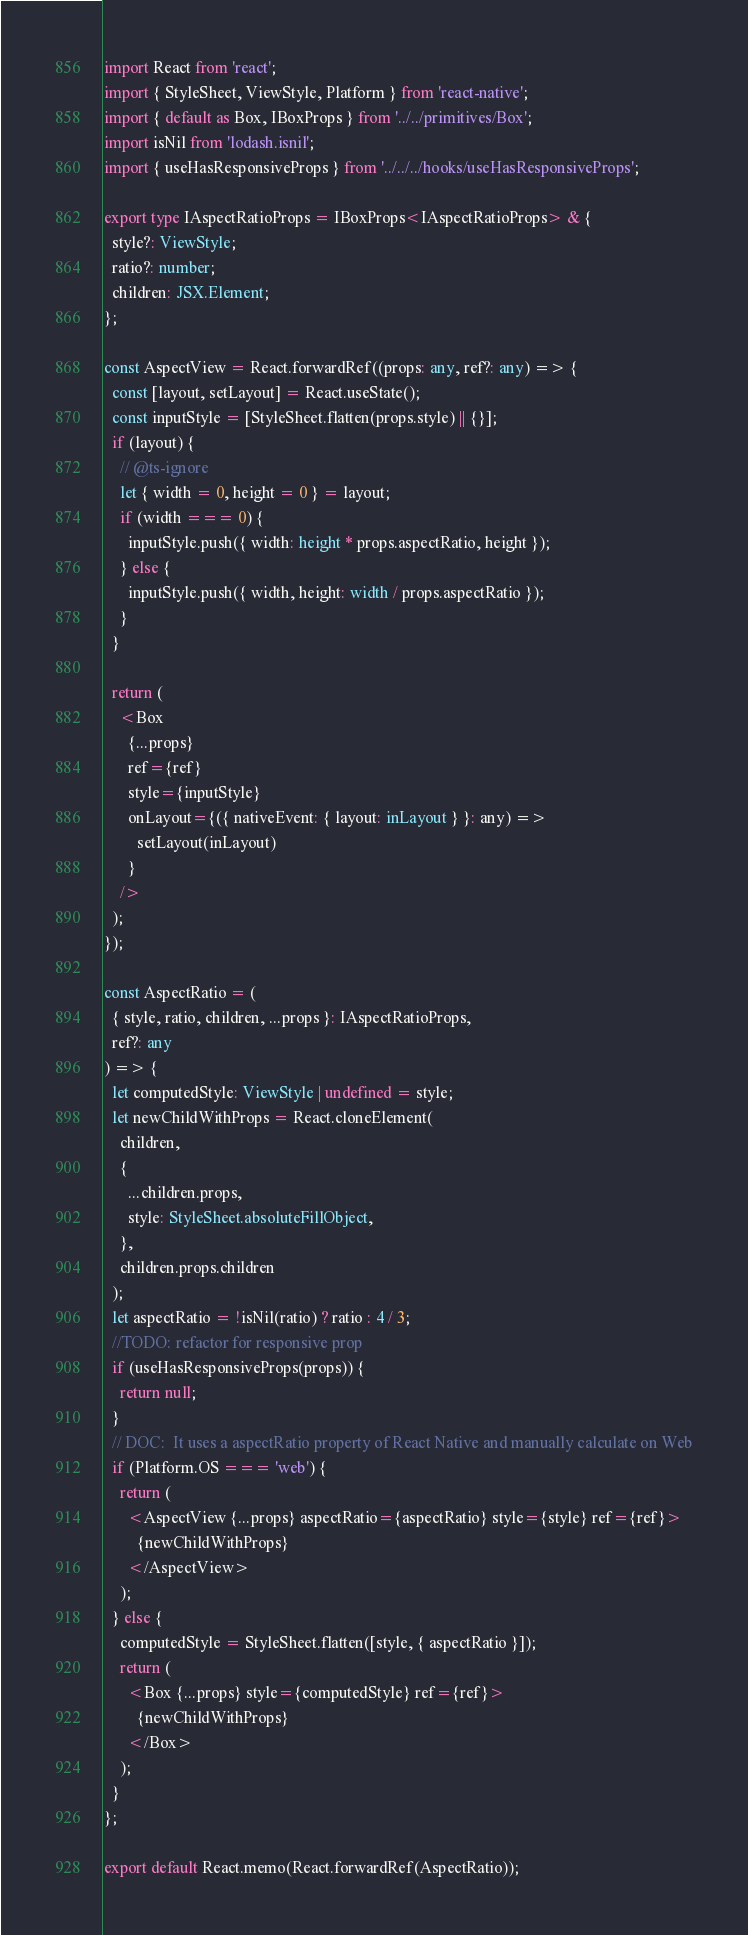Convert code to text. <code><loc_0><loc_0><loc_500><loc_500><_TypeScript_>import React from 'react';
import { StyleSheet, ViewStyle, Platform } from 'react-native';
import { default as Box, IBoxProps } from '../../primitives/Box';
import isNil from 'lodash.isnil';
import { useHasResponsiveProps } from '../../../hooks/useHasResponsiveProps';

export type IAspectRatioProps = IBoxProps<IAspectRatioProps> & {
  style?: ViewStyle;
  ratio?: number;
  children: JSX.Element;
};

const AspectView = React.forwardRef((props: any, ref?: any) => {
  const [layout, setLayout] = React.useState();
  const inputStyle = [StyleSheet.flatten(props.style) || {}];
  if (layout) {
    // @ts-ignore
    let { width = 0, height = 0 } = layout;
    if (width === 0) {
      inputStyle.push({ width: height * props.aspectRatio, height });
    } else {
      inputStyle.push({ width, height: width / props.aspectRatio });
    }
  }

  return (
    <Box
      {...props}
      ref={ref}
      style={inputStyle}
      onLayout={({ nativeEvent: { layout: inLayout } }: any) =>
        setLayout(inLayout)
      }
    />
  );
});

const AspectRatio = (
  { style, ratio, children, ...props }: IAspectRatioProps,
  ref?: any
) => {
  let computedStyle: ViewStyle | undefined = style;
  let newChildWithProps = React.cloneElement(
    children,
    {
      ...children.props,
      style: StyleSheet.absoluteFillObject,
    },
    children.props.children
  );
  let aspectRatio = !isNil(ratio) ? ratio : 4 / 3;
  //TODO: refactor for responsive prop
  if (useHasResponsiveProps(props)) {
    return null;
  }
  // DOC:  It uses a aspectRatio property of React Native and manually calculate on Web
  if (Platform.OS === 'web') {
    return (
      <AspectView {...props} aspectRatio={aspectRatio} style={style} ref={ref}>
        {newChildWithProps}
      </AspectView>
    );
  } else {
    computedStyle = StyleSheet.flatten([style, { aspectRatio }]);
    return (
      <Box {...props} style={computedStyle} ref={ref}>
        {newChildWithProps}
      </Box>
    );
  }
};

export default React.memo(React.forwardRef(AspectRatio));
</code> 